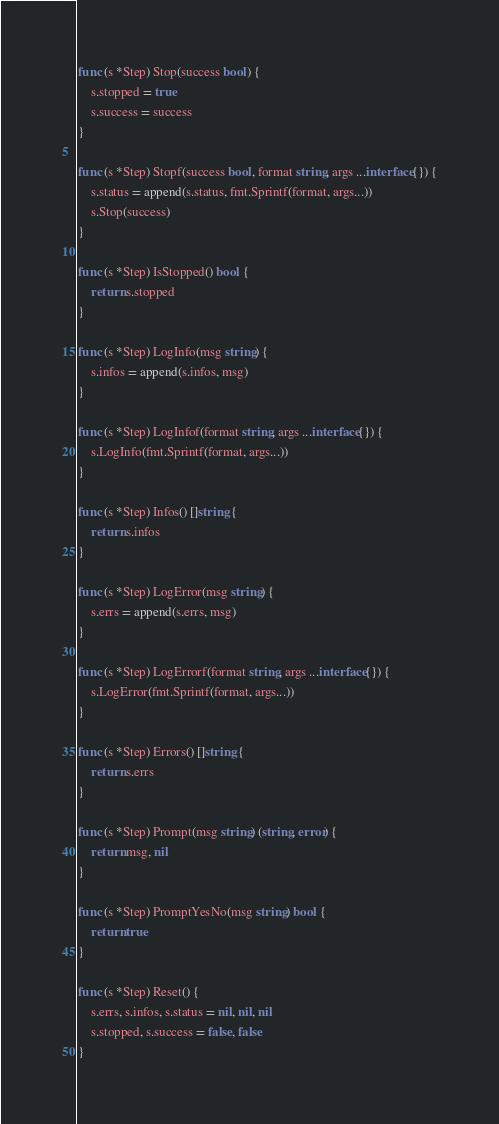Convert code to text. <code><loc_0><loc_0><loc_500><loc_500><_Go_>
func (s *Step) Stop(success bool) {
	s.stopped = true
	s.success = success
}

func (s *Step) Stopf(success bool, format string, args ...interface{}) {
	s.status = append(s.status, fmt.Sprintf(format, args...))
	s.Stop(success)
}

func (s *Step) IsStopped() bool {
	return s.stopped
}

func (s *Step) LogInfo(msg string) {
	s.infos = append(s.infos, msg)
}

func (s *Step) LogInfof(format string, args ...interface{}) {
	s.LogInfo(fmt.Sprintf(format, args...))
}

func (s *Step) Infos() []string {
	return s.infos
}

func (s *Step) LogError(msg string) {
	s.errs = append(s.errs, msg)
}

func (s *Step) LogErrorf(format string, args ...interface{}) {
	s.LogError(fmt.Sprintf(format, args...))
}

func (s *Step) Errors() []string {
	return s.errs
}

func (s *Step) Prompt(msg string) (string, error) {
	return msg, nil
}

func (s *Step) PromptYesNo(msg string) bool {
	return true
}

func (s *Step) Reset() {
	s.errs, s.infos, s.status = nil, nil, nil
	s.stopped, s.success = false, false
}
</code> 